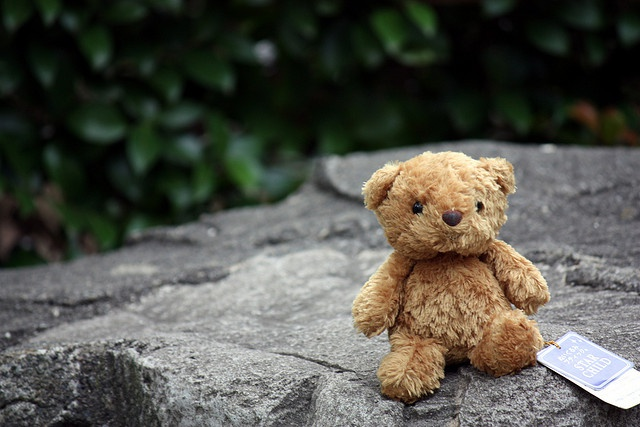Describe the objects in this image and their specific colors. I can see a teddy bear in black, tan, gray, and maroon tones in this image. 